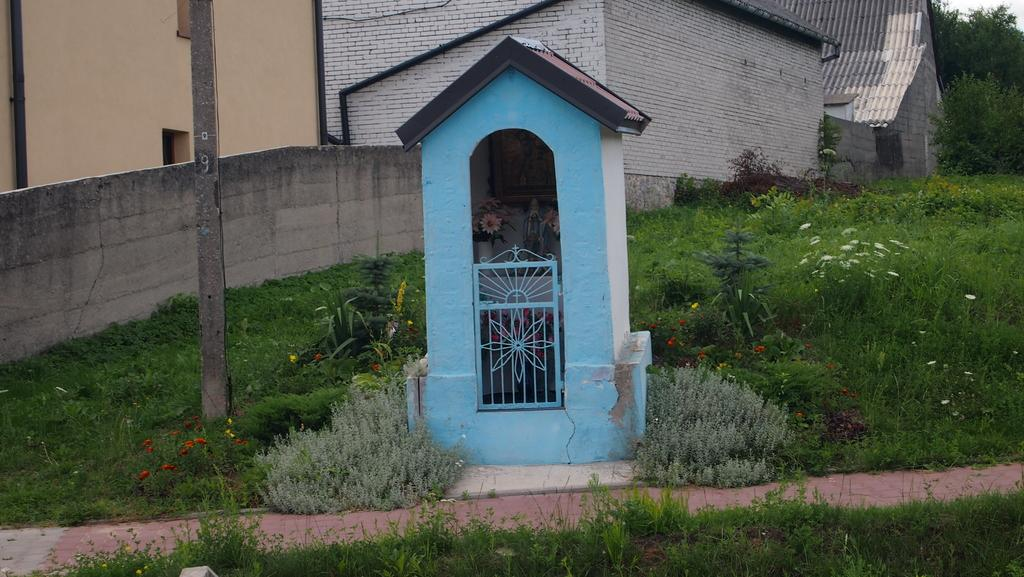What type of vegetation is at the bottom of the image? There is grass at the bottom of the image. What other types of vegetation can be seen in the image? There are plants and flowers in the image. What structures are present in the image? There is a pole and a wall in the image. What can be seen behind the wall in the image? Buildings and trees are visible behind the wall in the image. What type of jeans is the swing wearing in the image? There is no swing or jeans present in the image. 